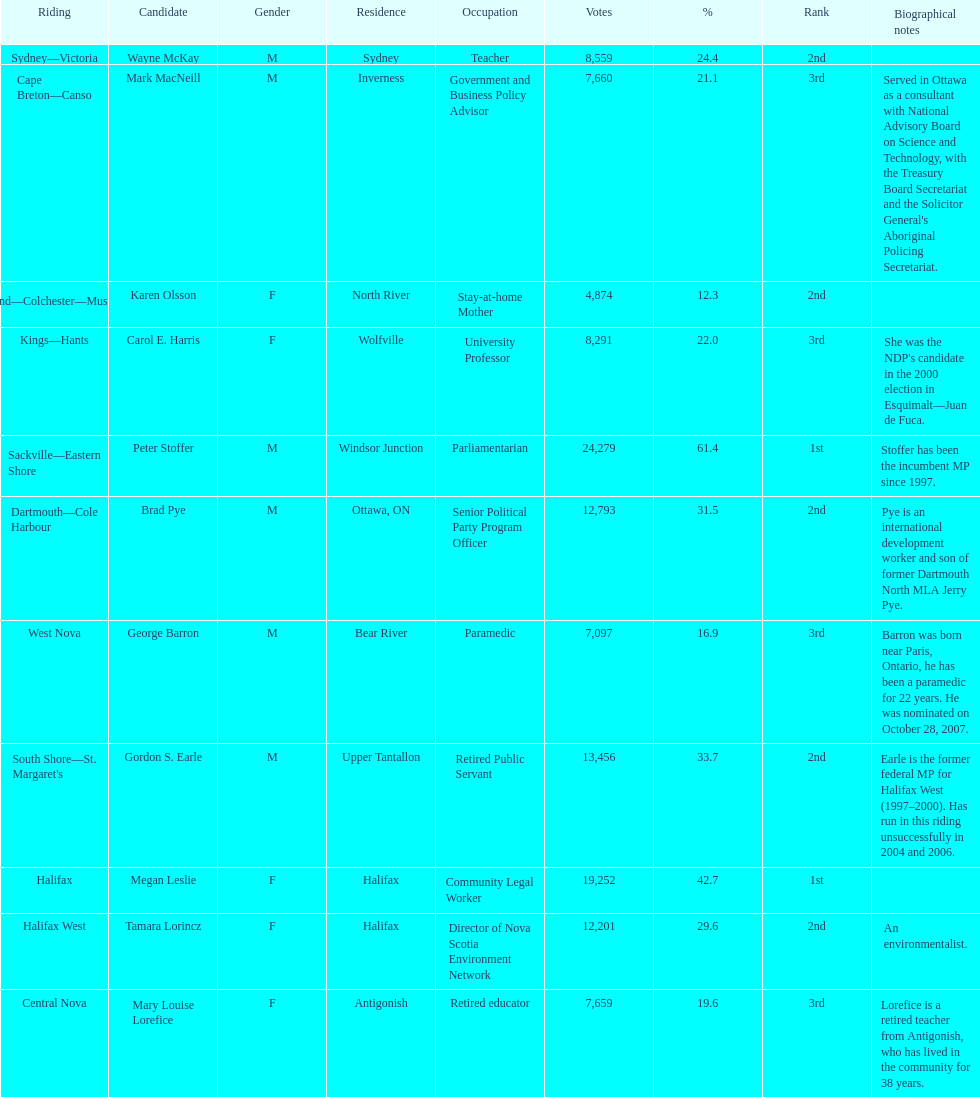Who are all the candidates? Mark MacNeill, Mary Louise Lorefice, Karen Olsson, Brad Pye, Megan Leslie, Tamara Lorincz, Carol E. Harris, Peter Stoffer, Gordon S. Earle, Wayne McKay, George Barron. Give me the full table as a dictionary. {'header': ['Riding', 'Candidate', 'Gender', 'Residence', 'Occupation', 'Votes', '%', 'Rank', 'Biographical notes'], 'rows': [['Sydney—Victoria', 'Wayne McKay', 'M', 'Sydney', 'Teacher', '8,559', '24.4', '2nd', ''], ['Cape Breton—Canso', 'Mark MacNeill', 'M', 'Inverness', 'Government and Business Policy Advisor', '7,660', '21.1', '3rd', "Served in Ottawa as a consultant with National Advisory Board on Science and Technology, with the Treasury Board Secretariat and the Solicitor General's Aboriginal Policing Secretariat."], ['Cumberland—Colchester—Musquodoboit Valley', 'Karen Olsson', 'F', 'North River', 'Stay-at-home Mother', '4,874', '12.3', '2nd', ''], ['Kings—Hants', 'Carol E. Harris', 'F', 'Wolfville', 'University Professor', '8,291', '22.0', '3rd', "She was the NDP's candidate in the 2000 election in Esquimalt—Juan de Fuca."], ['Sackville—Eastern Shore', 'Peter Stoffer', 'M', 'Windsor Junction', 'Parliamentarian', '24,279', '61.4', '1st', 'Stoffer has been the incumbent MP since 1997.'], ['Dartmouth—Cole Harbour', 'Brad Pye', 'M', 'Ottawa, ON', 'Senior Political Party Program Officer', '12,793', '31.5', '2nd', 'Pye is an international development worker and son of former Dartmouth North MLA Jerry Pye.'], ['West Nova', 'George Barron', 'M', 'Bear River', 'Paramedic', '7,097', '16.9', '3rd', 'Barron was born near Paris, Ontario, he has been a paramedic for 22 years. He was nominated on October 28, 2007.'], ["South Shore—St. Margaret's", 'Gordon S. Earle', 'M', 'Upper Tantallon', 'Retired Public Servant', '13,456', '33.7', '2nd', 'Earle is the former federal MP for Halifax West (1997–2000). Has run in this riding unsuccessfully in 2004 and 2006.'], ['Halifax', 'Megan Leslie', 'F', 'Halifax', 'Community Legal Worker', '19,252', '42.7', '1st', ''], ['Halifax West', 'Tamara Lorincz', 'F', 'Halifax', 'Director of Nova Scotia Environment Network', '12,201', '29.6', '2nd', 'An environmentalist.'], ['Central Nova', 'Mary Louise Lorefice', 'F', 'Antigonish', 'Retired educator', '7,659', '19.6', '3rd', 'Lorefice is a retired teacher from Antigonish, who has lived in the community for 38 years.']]} How many votes did they receive? 7,660, 7,659, 4,874, 12,793, 19,252, 12,201, 8,291, 24,279, 13,456, 8,559, 7,097. And of those, how many were for megan leslie? 19,252. 